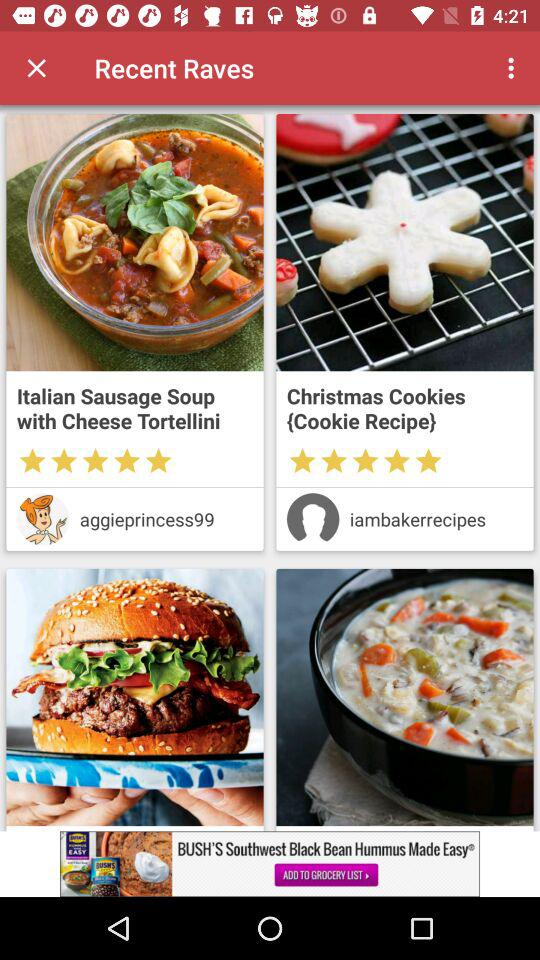What is rating of the dish?
When the provided information is insufficient, respond with <no answer>. <no answer> 